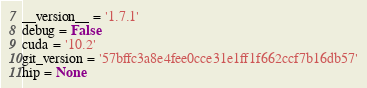Convert code to text. <code><loc_0><loc_0><loc_500><loc_500><_Python_>__version__ = '1.7.1'
debug = False
cuda = '10.2'
git_version = '57bffc3a8e4fee0cce31e1ff1f662ccf7b16db57'
hip = None
</code> 